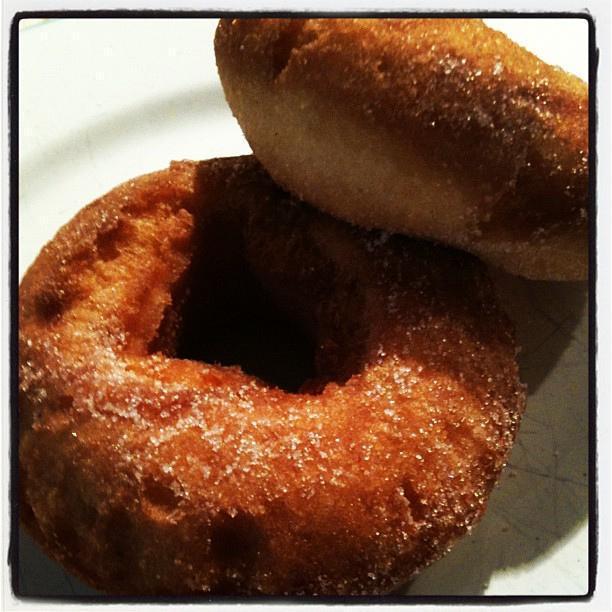How many donuts are there?
Give a very brief answer. 2. 